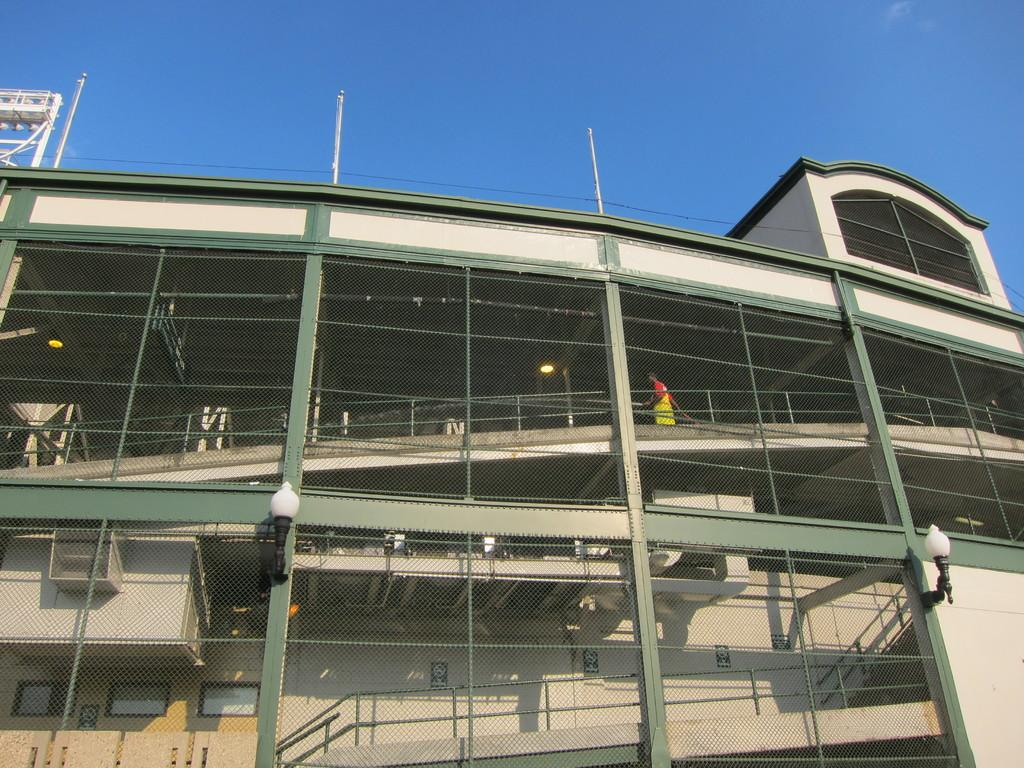What is the main structure in the foreground of the image? There is a building in the foreground of the image. Are there any objects near the building? Yes, there are two lamps near the building. Can you describe the man's location in the image? The man is standing near a railing inside the building. What can be seen at the top of the image? The sky is visible at the top of the image. What type of canvas is being used to paint the lamps in the image? There is no canvas or painting activity depicted in the image; it shows a building, lamps, and a man standing near a railing. 